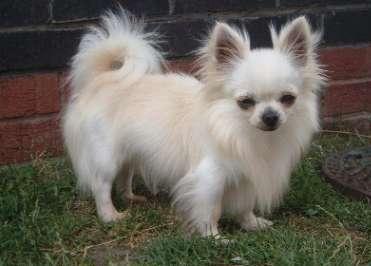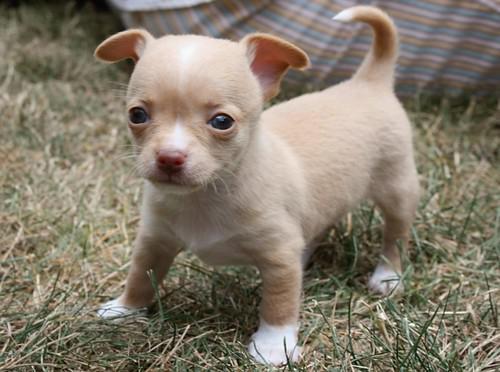The first image is the image on the left, the second image is the image on the right. For the images shown, is this caption "Each image contains one dog on a leash." true? Answer yes or no. No. 